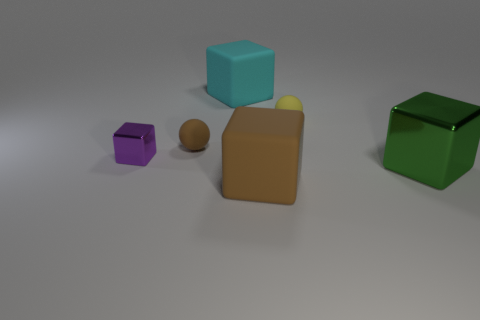What number of metal things are on the left side of the big matte thing that is on the right side of the cyan object?
Your answer should be compact. 1. Are there fewer metal blocks in front of the big brown matte thing than cubes?
Offer a terse response. Yes. What shape is the metal object to the left of the matte cube behind the small ball to the right of the tiny brown ball?
Your answer should be compact. Cube. Does the tiny brown matte thing have the same shape as the purple object?
Keep it short and to the point. No. What number of other things are there of the same shape as the large green object?
Ensure brevity in your answer.  3. There is a rubber sphere that is the same size as the yellow matte object; what is its color?
Provide a short and direct response. Brown. Are there the same number of metal things in front of the cyan matte object and large green metallic blocks?
Your answer should be very brief. No. There is a large thing that is on the left side of the yellow matte thing and in front of the purple metal object; what is its shape?
Offer a terse response. Cube. Do the yellow sphere and the cyan object have the same size?
Provide a succinct answer. No. Is there a large green object that has the same material as the purple block?
Keep it short and to the point. Yes. 